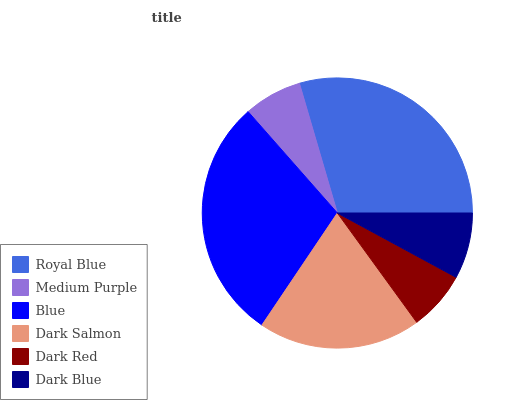Is Medium Purple the minimum?
Answer yes or no. Yes. Is Royal Blue the maximum?
Answer yes or no. Yes. Is Blue the minimum?
Answer yes or no. No. Is Blue the maximum?
Answer yes or no. No. Is Blue greater than Medium Purple?
Answer yes or no. Yes. Is Medium Purple less than Blue?
Answer yes or no. Yes. Is Medium Purple greater than Blue?
Answer yes or no. No. Is Blue less than Medium Purple?
Answer yes or no. No. Is Dark Salmon the high median?
Answer yes or no. Yes. Is Dark Blue the low median?
Answer yes or no. Yes. Is Blue the high median?
Answer yes or no. No. Is Dark Red the low median?
Answer yes or no. No. 